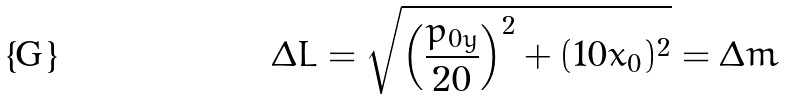<formula> <loc_0><loc_0><loc_500><loc_500>\Delta L = \sqrt { \left ( \frac { p _ { 0 y } } { 2 0 } \right ) ^ { 2 } + ( 1 0 x _ { 0 } ) ^ { 2 } } = \Delta m</formula> 